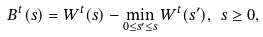<formula> <loc_0><loc_0><loc_500><loc_500>B ^ { t } ( s ) = W ^ { t } ( s ) - \min _ { 0 \leq s ^ { \prime } \leq s } W ^ { t } ( s ^ { \prime } ) , \ s \geq 0 ,</formula> 